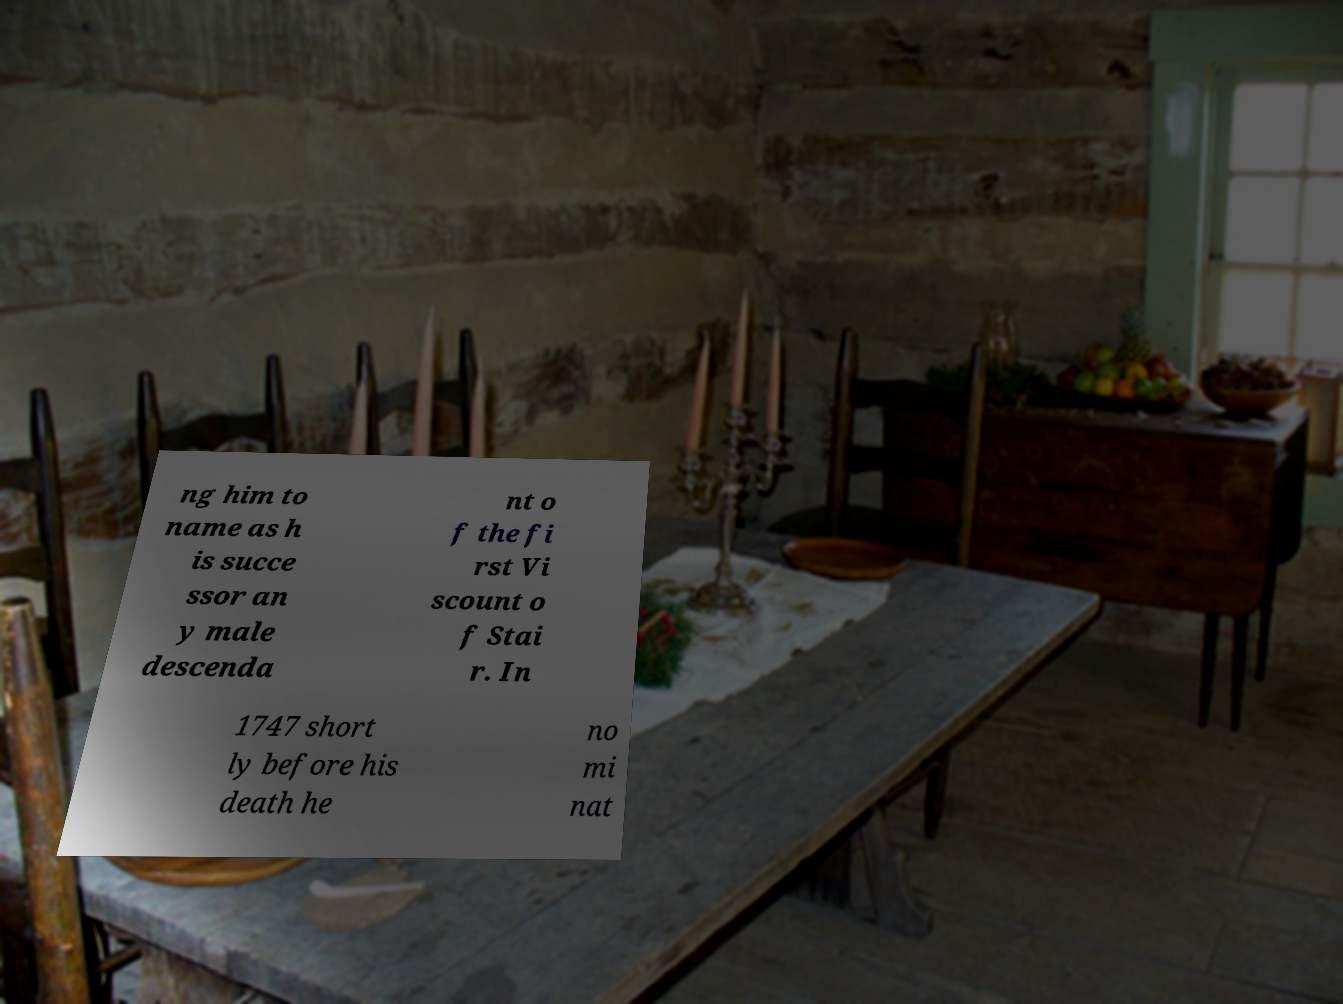Could you assist in decoding the text presented in this image and type it out clearly? ng him to name as h is succe ssor an y male descenda nt o f the fi rst Vi scount o f Stai r. In 1747 short ly before his death he no mi nat 